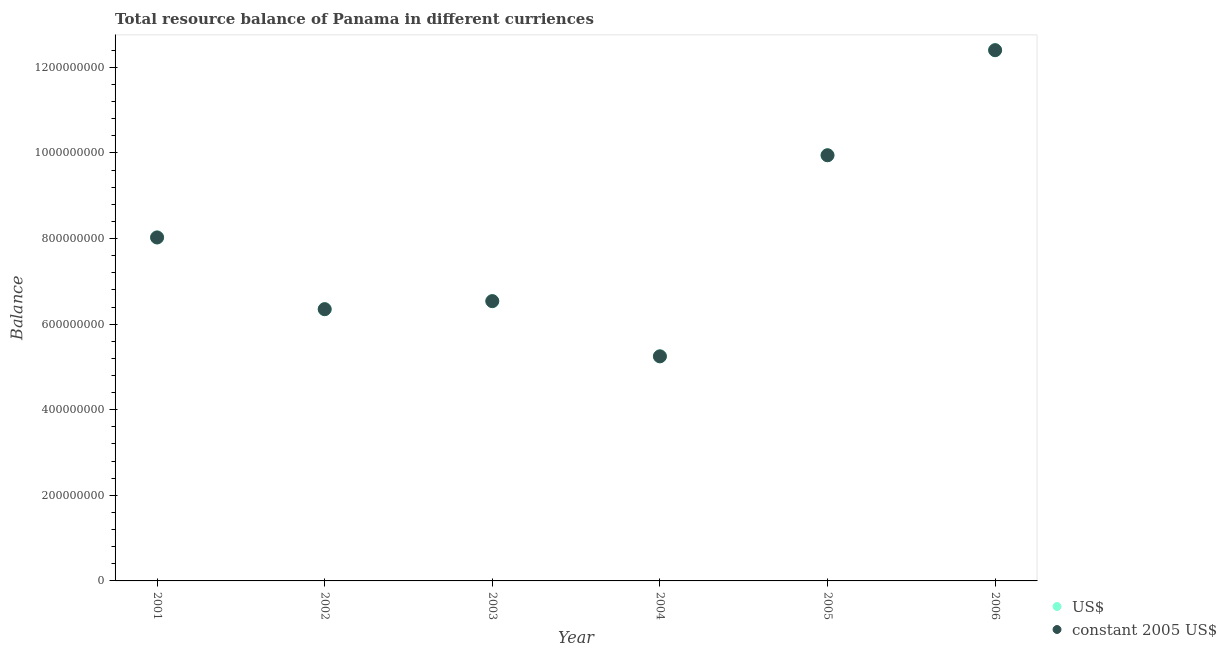How many different coloured dotlines are there?
Your answer should be compact. 2. What is the resource balance in constant us$ in 2001?
Give a very brief answer. 8.03e+08. Across all years, what is the maximum resource balance in us$?
Offer a terse response. 1.24e+09. Across all years, what is the minimum resource balance in us$?
Give a very brief answer. 5.25e+08. In which year was the resource balance in constant us$ maximum?
Your response must be concise. 2006. What is the total resource balance in constant us$ in the graph?
Ensure brevity in your answer.  4.85e+09. What is the difference between the resource balance in constant us$ in 2003 and that in 2005?
Your answer should be very brief. -3.41e+08. What is the difference between the resource balance in constant us$ in 2001 and the resource balance in us$ in 2004?
Offer a very short reply. 2.78e+08. What is the average resource balance in us$ per year?
Make the answer very short. 8.09e+08. In the year 2005, what is the difference between the resource balance in constant us$ and resource balance in us$?
Make the answer very short. 0. In how many years, is the resource balance in us$ greater than 520000000 units?
Your answer should be compact. 6. What is the ratio of the resource balance in constant us$ in 2002 to that in 2005?
Your answer should be very brief. 0.64. Is the resource balance in constant us$ in 2003 less than that in 2006?
Your response must be concise. Yes. Is the difference between the resource balance in us$ in 2001 and 2003 greater than the difference between the resource balance in constant us$ in 2001 and 2003?
Ensure brevity in your answer.  No. What is the difference between the highest and the second highest resource balance in constant us$?
Ensure brevity in your answer.  2.46e+08. What is the difference between the highest and the lowest resource balance in constant us$?
Make the answer very short. 7.15e+08. In how many years, is the resource balance in constant us$ greater than the average resource balance in constant us$ taken over all years?
Offer a very short reply. 2. Is the resource balance in constant us$ strictly greater than the resource balance in us$ over the years?
Give a very brief answer. No. Is the resource balance in constant us$ strictly less than the resource balance in us$ over the years?
Keep it short and to the point. No. What is the difference between two consecutive major ticks on the Y-axis?
Your answer should be very brief. 2.00e+08. Are the values on the major ticks of Y-axis written in scientific E-notation?
Provide a succinct answer. No. Does the graph contain grids?
Offer a terse response. No. Where does the legend appear in the graph?
Make the answer very short. Bottom right. How many legend labels are there?
Provide a short and direct response. 2. What is the title of the graph?
Offer a very short reply. Total resource balance of Panama in different curriences. Does "Urban" appear as one of the legend labels in the graph?
Offer a very short reply. No. What is the label or title of the X-axis?
Make the answer very short. Year. What is the label or title of the Y-axis?
Give a very brief answer. Balance. What is the Balance in US$ in 2001?
Provide a succinct answer. 8.03e+08. What is the Balance of constant 2005 US$ in 2001?
Offer a very short reply. 8.03e+08. What is the Balance in US$ in 2002?
Make the answer very short. 6.35e+08. What is the Balance of constant 2005 US$ in 2002?
Offer a terse response. 6.35e+08. What is the Balance in US$ in 2003?
Keep it short and to the point. 6.54e+08. What is the Balance of constant 2005 US$ in 2003?
Keep it short and to the point. 6.54e+08. What is the Balance of US$ in 2004?
Your answer should be compact. 5.25e+08. What is the Balance in constant 2005 US$ in 2004?
Provide a short and direct response. 5.25e+08. What is the Balance of US$ in 2005?
Ensure brevity in your answer.  9.95e+08. What is the Balance of constant 2005 US$ in 2005?
Your answer should be compact. 9.95e+08. What is the Balance in US$ in 2006?
Ensure brevity in your answer.  1.24e+09. What is the Balance of constant 2005 US$ in 2006?
Your response must be concise. 1.24e+09. Across all years, what is the maximum Balance in US$?
Your answer should be compact. 1.24e+09. Across all years, what is the maximum Balance of constant 2005 US$?
Ensure brevity in your answer.  1.24e+09. Across all years, what is the minimum Balance of US$?
Offer a very short reply. 5.25e+08. Across all years, what is the minimum Balance of constant 2005 US$?
Give a very brief answer. 5.25e+08. What is the total Balance of US$ in the graph?
Make the answer very short. 4.85e+09. What is the total Balance of constant 2005 US$ in the graph?
Provide a succinct answer. 4.85e+09. What is the difference between the Balance of US$ in 2001 and that in 2002?
Your response must be concise. 1.68e+08. What is the difference between the Balance in constant 2005 US$ in 2001 and that in 2002?
Your response must be concise. 1.68e+08. What is the difference between the Balance of US$ in 2001 and that in 2003?
Provide a succinct answer. 1.49e+08. What is the difference between the Balance of constant 2005 US$ in 2001 and that in 2003?
Offer a very short reply. 1.49e+08. What is the difference between the Balance in US$ in 2001 and that in 2004?
Your answer should be compact. 2.78e+08. What is the difference between the Balance of constant 2005 US$ in 2001 and that in 2004?
Provide a short and direct response. 2.78e+08. What is the difference between the Balance in US$ in 2001 and that in 2005?
Make the answer very short. -1.92e+08. What is the difference between the Balance of constant 2005 US$ in 2001 and that in 2005?
Offer a very short reply. -1.92e+08. What is the difference between the Balance in US$ in 2001 and that in 2006?
Give a very brief answer. -4.38e+08. What is the difference between the Balance of constant 2005 US$ in 2001 and that in 2006?
Your answer should be very brief. -4.38e+08. What is the difference between the Balance of US$ in 2002 and that in 2003?
Provide a short and direct response. -1.88e+07. What is the difference between the Balance in constant 2005 US$ in 2002 and that in 2003?
Your response must be concise. -1.88e+07. What is the difference between the Balance in US$ in 2002 and that in 2004?
Your answer should be compact. 1.10e+08. What is the difference between the Balance of constant 2005 US$ in 2002 and that in 2004?
Your answer should be compact. 1.10e+08. What is the difference between the Balance of US$ in 2002 and that in 2005?
Make the answer very short. -3.60e+08. What is the difference between the Balance in constant 2005 US$ in 2002 and that in 2005?
Your answer should be compact. -3.60e+08. What is the difference between the Balance in US$ in 2002 and that in 2006?
Offer a terse response. -6.05e+08. What is the difference between the Balance of constant 2005 US$ in 2002 and that in 2006?
Offer a terse response. -6.05e+08. What is the difference between the Balance in US$ in 2003 and that in 2004?
Your answer should be compact. 1.29e+08. What is the difference between the Balance of constant 2005 US$ in 2003 and that in 2004?
Your answer should be compact. 1.29e+08. What is the difference between the Balance in US$ in 2003 and that in 2005?
Provide a succinct answer. -3.41e+08. What is the difference between the Balance in constant 2005 US$ in 2003 and that in 2005?
Your answer should be very brief. -3.41e+08. What is the difference between the Balance in US$ in 2003 and that in 2006?
Provide a succinct answer. -5.86e+08. What is the difference between the Balance in constant 2005 US$ in 2003 and that in 2006?
Provide a short and direct response. -5.86e+08. What is the difference between the Balance of US$ in 2004 and that in 2005?
Ensure brevity in your answer.  -4.70e+08. What is the difference between the Balance of constant 2005 US$ in 2004 and that in 2005?
Give a very brief answer. -4.70e+08. What is the difference between the Balance in US$ in 2004 and that in 2006?
Provide a succinct answer. -7.15e+08. What is the difference between the Balance in constant 2005 US$ in 2004 and that in 2006?
Offer a very short reply. -7.15e+08. What is the difference between the Balance of US$ in 2005 and that in 2006?
Give a very brief answer. -2.46e+08. What is the difference between the Balance of constant 2005 US$ in 2005 and that in 2006?
Provide a succinct answer. -2.46e+08. What is the difference between the Balance of US$ in 2001 and the Balance of constant 2005 US$ in 2002?
Your response must be concise. 1.68e+08. What is the difference between the Balance in US$ in 2001 and the Balance in constant 2005 US$ in 2003?
Make the answer very short. 1.49e+08. What is the difference between the Balance in US$ in 2001 and the Balance in constant 2005 US$ in 2004?
Keep it short and to the point. 2.78e+08. What is the difference between the Balance of US$ in 2001 and the Balance of constant 2005 US$ in 2005?
Keep it short and to the point. -1.92e+08. What is the difference between the Balance of US$ in 2001 and the Balance of constant 2005 US$ in 2006?
Your answer should be very brief. -4.38e+08. What is the difference between the Balance of US$ in 2002 and the Balance of constant 2005 US$ in 2003?
Provide a short and direct response. -1.88e+07. What is the difference between the Balance in US$ in 2002 and the Balance in constant 2005 US$ in 2004?
Make the answer very short. 1.10e+08. What is the difference between the Balance in US$ in 2002 and the Balance in constant 2005 US$ in 2005?
Offer a terse response. -3.60e+08. What is the difference between the Balance in US$ in 2002 and the Balance in constant 2005 US$ in 2006?
Your answer should be very brief. -6.05e+08. What is the difference between the Balance of US$ in 2003 and the Balance of constant 2005 US$ in 2004?
Offer a terse response. 1.29e+08. What is the difference between the Balance in US$ in 2003 and the Balance in constant 2005 US$ in 2005?
Make the answer very short. -3.41e+08. What is the difference between the Balance in US$ in 2003 and the Balance in constant 2005 US$ in 2006?
Keep it short and to the point. -5.86e+08. What is the difference between the Balance of US$ in 2004 and the Balance of constant 2005 US$ in 2005?
Offer a very short reply. -4.70e+08. What is the difference between the Balance in US$ in 2004 and the Balance in constant 2005 US$ in 2006?
Give a very brief answer. -7.15e+08. What is the difference between the Balance of US$ in 2005 and the Balance of constant 2005 US$ in 2006?
Provide a succinct answer. -2.46e+08. What is the average Balance of US$ per year?
Provide a succinct answer. 8.09e+08. What is the average Balance in constant 2005 US$ per year?
Your response must be concise. 8.09e+08. In the year 2001, what is the difference between the Balance in US$ and Balance in constant 2005 US$?
Ensure brevity in your answer.  0. In the year 2003, what is the difference between the Balance of US$ and Balance of constant 2005 US$?
Offer a terse response. 0. What is the ratio of the Balance in US$ in 2001 to that in 2002?
Offer a terse response. 1.26. What is the ratio of the Balance in constant 2005 US$ in 2001 to that in 2002?
Your answer should be very brief. 1.26. What is the ratio of the Balance in US$ in 2001 to that in 2003?
Make the answer very short. 1.23. What is the ratio of the Balance of constant 2005 US$ in 2001 to that in 2003?
Offer a very short reply. 1.23. What is the ratio of the Balance in US$ in 2001 to that in 2004?
Your answer should be compact. 1.53. What is the ratio of the Balance of constant 2005 US$ in 2001 to that in 2004?
Provide a short and direct response. 1.53. What is the ratio of the Balance of US$ in 2001 to that in 2005?
Offer a very short reply. 0.81. What is the ratio of the Balance in constant 2005 US$ in 2001 to that in 2005?
Provide a short and direct response. 0.81. What is the ratio of the Balance of US$ in 2001 to that in 2006?
Provide a succinct answer. 0.65. What is the ratio of the Balance in constant 2005 US$ in 2001 to that in 2006?
Provide a succinct answer. 0.65. What is the ratio of the Balance in US$ in 2002 to that in 2003?
Your answer should be very brief. 0.97. What is the ratio of the Balance in constant 2005 US$ in 2002 to that in 2003?
Make the answer very short. 0.97. What is the ratio of the Balance of US$ in 2002 to that in 2004?
Offer a terse response. 1.21. What is the ratio of the Balance in constant 2005 US$ in 2002 to that in 2004?
Your answer should be compact. 1.21. What is the ratio of the Balance in US$ in 2002 to that in 2005?
Provide a succinct answer. 0.64. What is the ratio of the Balance of constant 2005 US$ in 2002 to that in 2005?
Offer a terse response. 0.64. What is the ratio of the Balance of US$ in 2002 to that in 2006?
Your answer should be compact. 0.51. What is the ratio of the Balance of constant 2005 US$ in 2002 to that in 2006?
Keep it short and to the point. 0.51. What is the ratio of the Balance in US$ in 2003 to that in 2004?
Ensure brevity in your answer.  1.25. What is the ratio of the Balance in constant 2005 US$ in 2003 to that in 2004?
Give a very brief answer. 1.25. What is the ratio of the Balance in US$ in 2003 to that in 2005?
Give a very brief answer. 0.66. What is the ratio of the Balance in constant 2005 US$ in 2003 to that in 2005?
Ensure brevity in your answer.  0.66. What is the ratio of the Balance of US$ in 2003 to that in 2006?
Provide a succinct answer. 0.53. What is the ratio of the Balance of constant 2005 US$ in 2003 to that in 2006?
Give a very brief answer. 0.53. What is the ratio of the Balance of US$ in 2004 to that in 2005?
Make the answer very short. 0.53. What is the ratio of the Balance in constant 2005 US$ in 2004 to that in 2005?
Keep it short and to the point. 0.53. What is the ratio of the Balance of US$ in 2004 to that in 2006?
Give a very brief answer. 0.42. What is the ratio of the Balance of constant 2005 US$ in 2004 to that in 2006?
Keep it short and to the point. 0.42. What is the ratio of the Balance in US$ in 2005 to that in 2006?
Your response must be concise. 0.8. What is the ratio of the Balance of constant 2005 US$ in 2005 to that in 2006?
Your answer should be compact. 0.8. What is the difference between the highest and the second highest Balance in US$?
Give a very brief answer. 2.46e+08. What is the difference between the highest and the second highest Balance in constant 2005 US$?
Your answer should be very brief. 2.46e+08. What is the difference between the highest and the lowest Balance of US$?
Provide a short and direct response. 7.15e+08. What is the difference between the highest and the lowest Balance in constant 2005 US$?
Make the answer very short. 7.15e+08. 